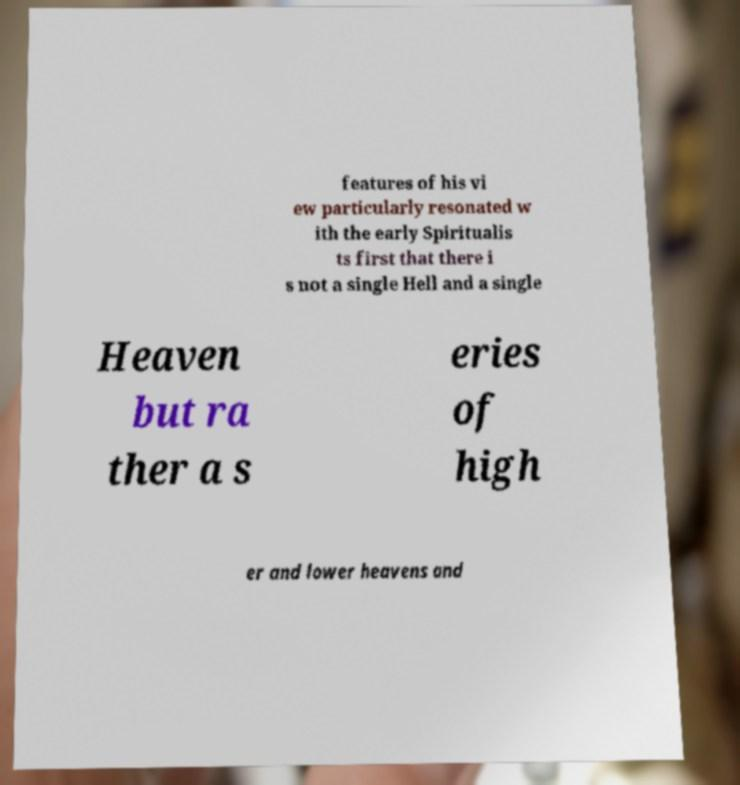Please read and relay the text visible in this image. What does it say? features of his vi ew particularly resonated w ith the early Spiritualis ts first that there i s not a single Hell and a single Heaven but ra ther a s eries of high er and lower heavens and 